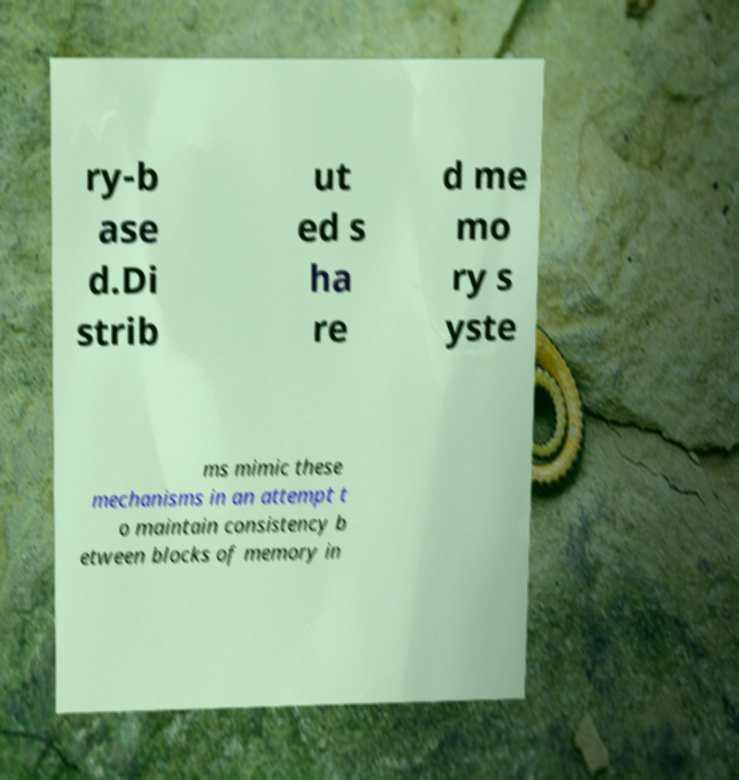Please read and relay the text visible in this image. What does it say? ry-b ase d.Di strib ut ed s ha re d me mo ry s yste ms mimic these mechanisms in an attempt t o maintain consistency b etween blocks of memory in 